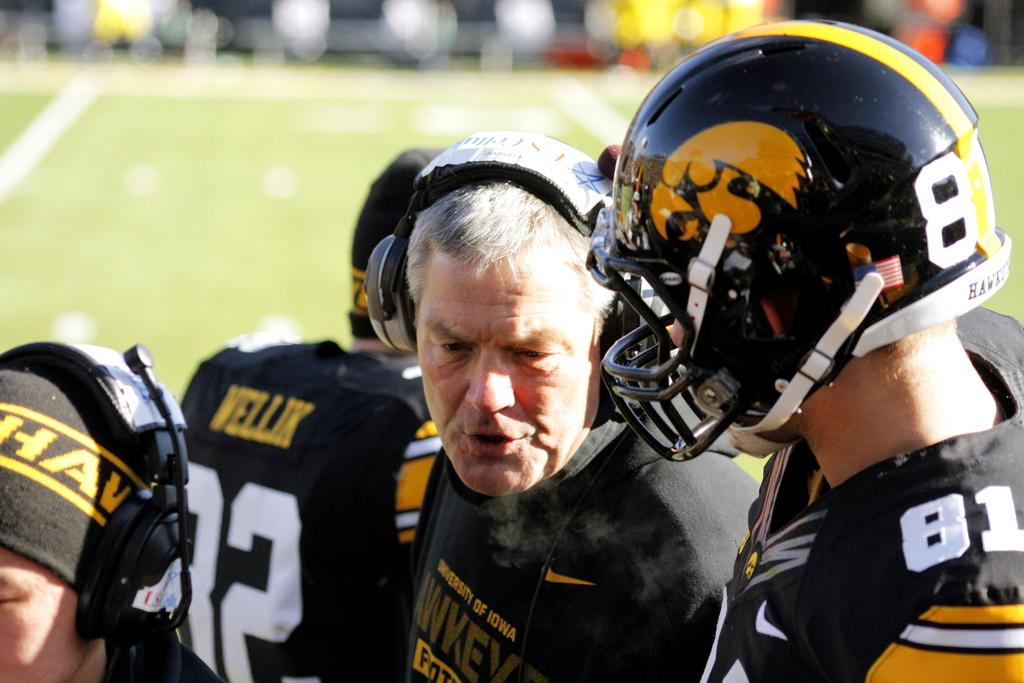What activity is taking place in the image? There are players on the playground in the image. What are the players doing? The players are standing. What protective gear are the players wearing? The players are wearing helmets. What color are the players' T-shirts? The players are wearing black T-shirts. What type of surface is visible in the background of the image? There is a grass surface in the background of the image. What type of nail art can be seen on the players' fingers in the image? There is no nail art visible on the players' fingers in the image, as they are wearing helmets and holding no objects. 